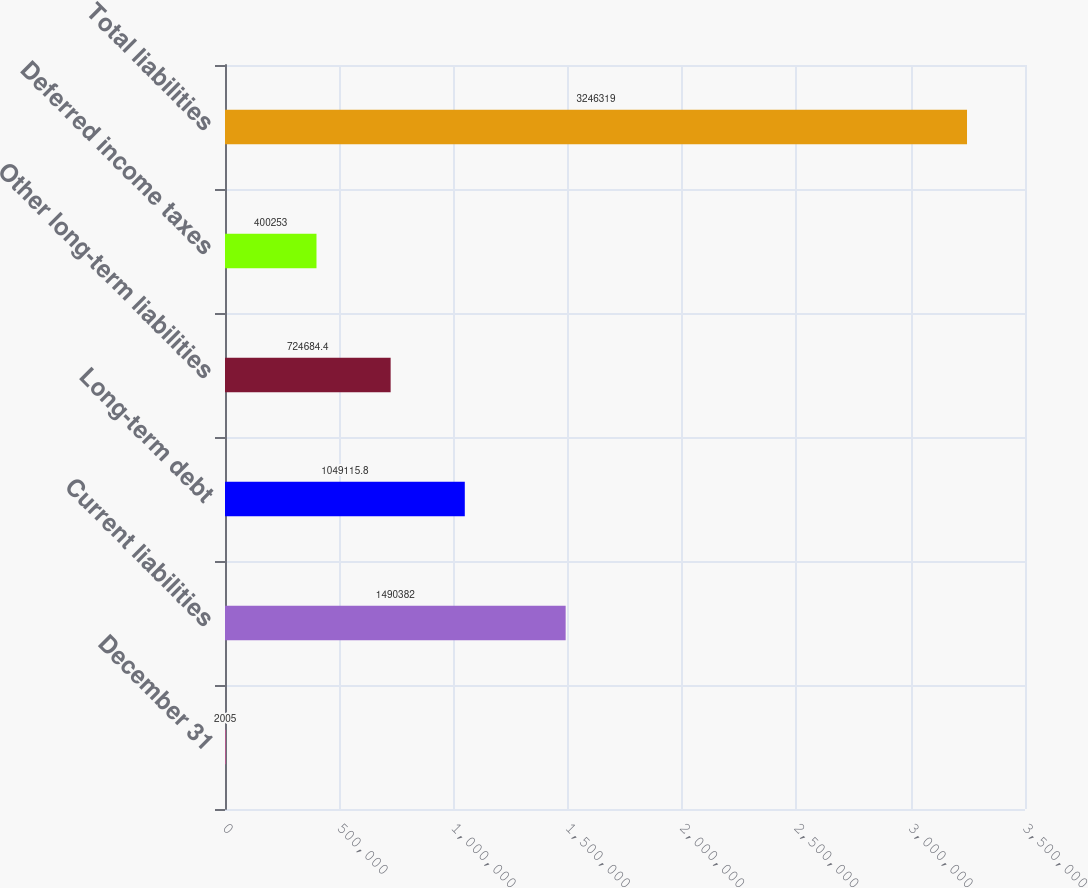Convert chart. <chart><loc_0><loc_0><loc_500><loc_500><bar_chart><fcel>December 31<fcel>Current liabilities<fcel>Long-term debt<fcel>Other long-term liabilities<fcel>Deferred income taxes<fcel>Total liabilities<nl><fcel>2005<fcel>1.49038e+06<fcel>1.04912e+06<fcel>724684<fcel>400253<fcel>3.24632e+06<nl></chart> 